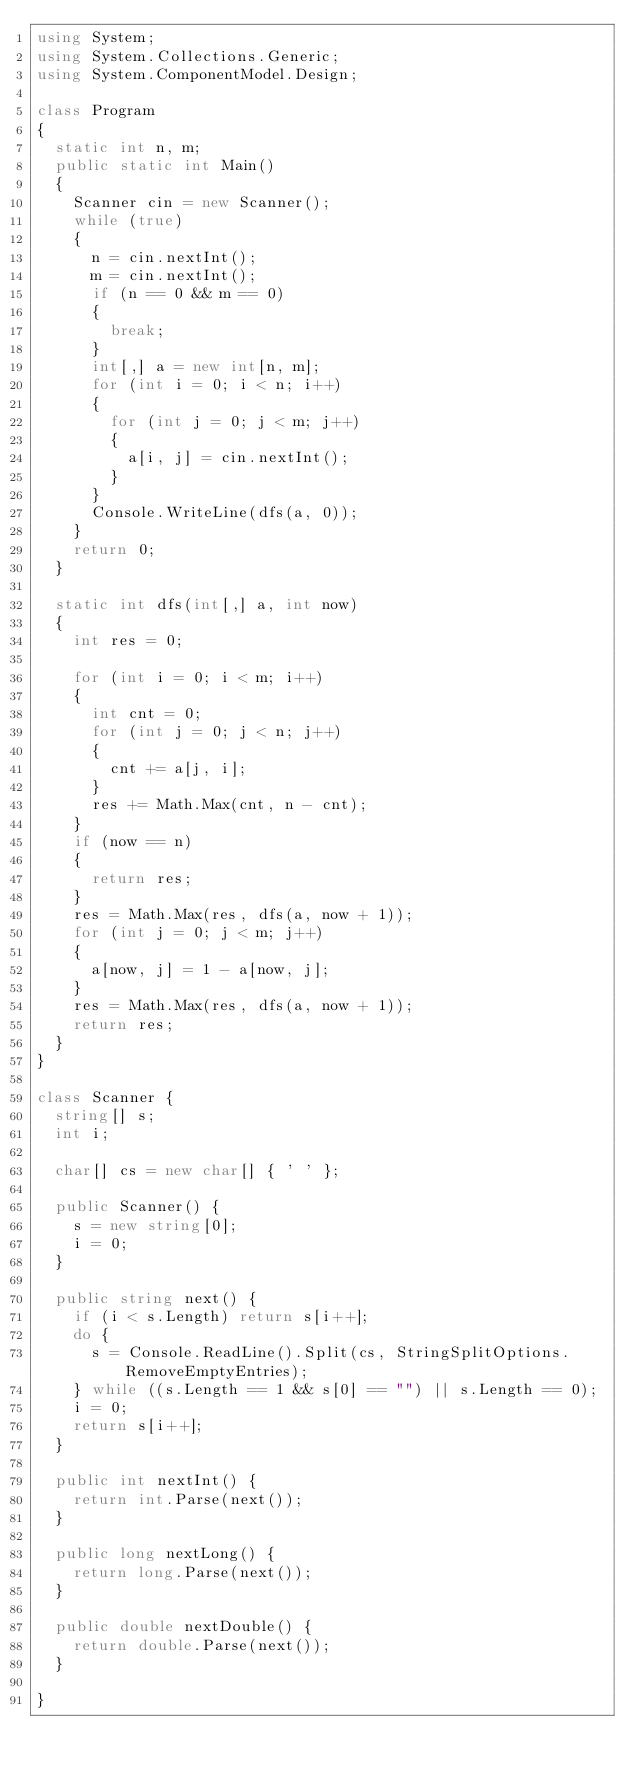<code> <loc_0><loc_0><loc_500><loc_500><_C#_>using System;
using System.Collections.Generic;
using System.ComponentModel.Design;

class Program
{
  static int n, m;
  public static int Main()
  {
    Scanner cin = new Scanner();
    while (true)
    {
      n = cin.nextInt();
      m = cin.nextInt();
      if (n == 0 && m == 0)
      {
        break;
      }
      int[,] a = new int[n, m];
      for (int i = 0; i < n; i++)
      {
        for (int j = 0; j < m; j++)
        {
          a[i, j] = cin.nextInt();
        }
      }
      Console.WriteLine(dfs(a, 0));
    }
    return 0;
  }

  static int dfs(int[,] a, int now)
  {
    int res = 0;
    
    for (int i = 0; i < m; i++)
    {
      int cnt = 0;
      for (int j = 0; j < n; j++)
      {
        cnt += a[j, i];
      }
      res += Math.Max(cnt, n - cnt);
    }
    if (now == n)
    {
      return res;
    }
    res = Math.Max(res, dfs(a, now + 1));
    for (int j = 0; j < m; j++)
    {
      a[now, j] = 1 - a[now, j];
    }
    res = Math.Max(res, dfs(a, now + 1));
    return res;
  }
}

class Scanner {
  string[] s;
  int i;

  char[] cs = new char[] { ' ' };

  public Scanner() {
    s = new string[0];
    i = 0;
  }

  public string next() {
    if (i < s.Length) return s[i++];
    do {
      s = Console.ReadLine().Split(cs, StringSplitOptions.RemoveEmptyEntries);
    } while ((s.Length == 1 && s[0] == "") || s.Length == 0);
    i = 0;
    return s[i++];
  }

  public int nextInt() {
    return int.Parse(next());
  }

  public long nextLong() {
    return long.Parse(next());
  }

  public double nextDouble() {
    return double.Parse(next());
  }

}</code> 